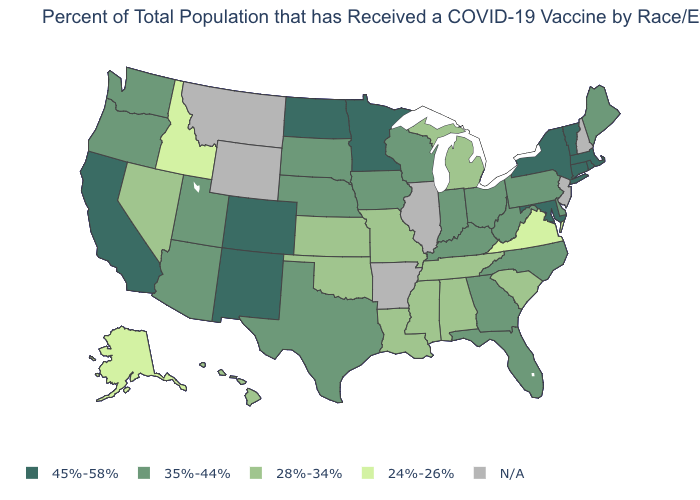What is the lowest value in the USA?
Short answer required. 24%-26%. What is the value of New Hampshire?
Be succinct. N/A. Does Alaska have the lowest value in the USA?
Keep it brief. Yes. What is the value of Hawaii?
Keep it brief. 28%-34%. What is the lowest value in the Northeast?
Concise answer only. 35%-44%. Which states have the lowest value in the USA?
Answer briefly. Alaska, Idaho, Virginia. What is the highest value in the USA?
Short answer required. 45%-58%. What is the value of Oklahoma?
Write a very short answer. 28%-34%. Name the states that have a value in the range 24%-26%?
Write a very short answer. Alaska, Idaho, Virginia. Which states have the lowest value in the USA?
Answer briefly. Alaska, Idaho, Virginia. What is the highest value in the West ?
Keep it brief. 45%-58%. What is the value of Georgia?
Quick response, please. 35%-44%. Which states have the lowest value in the USA?
Keep it brief. Alaska, Idaho, Virginia. What is the value of Nebraska?
Give a very brief answer. 35%-44%. 